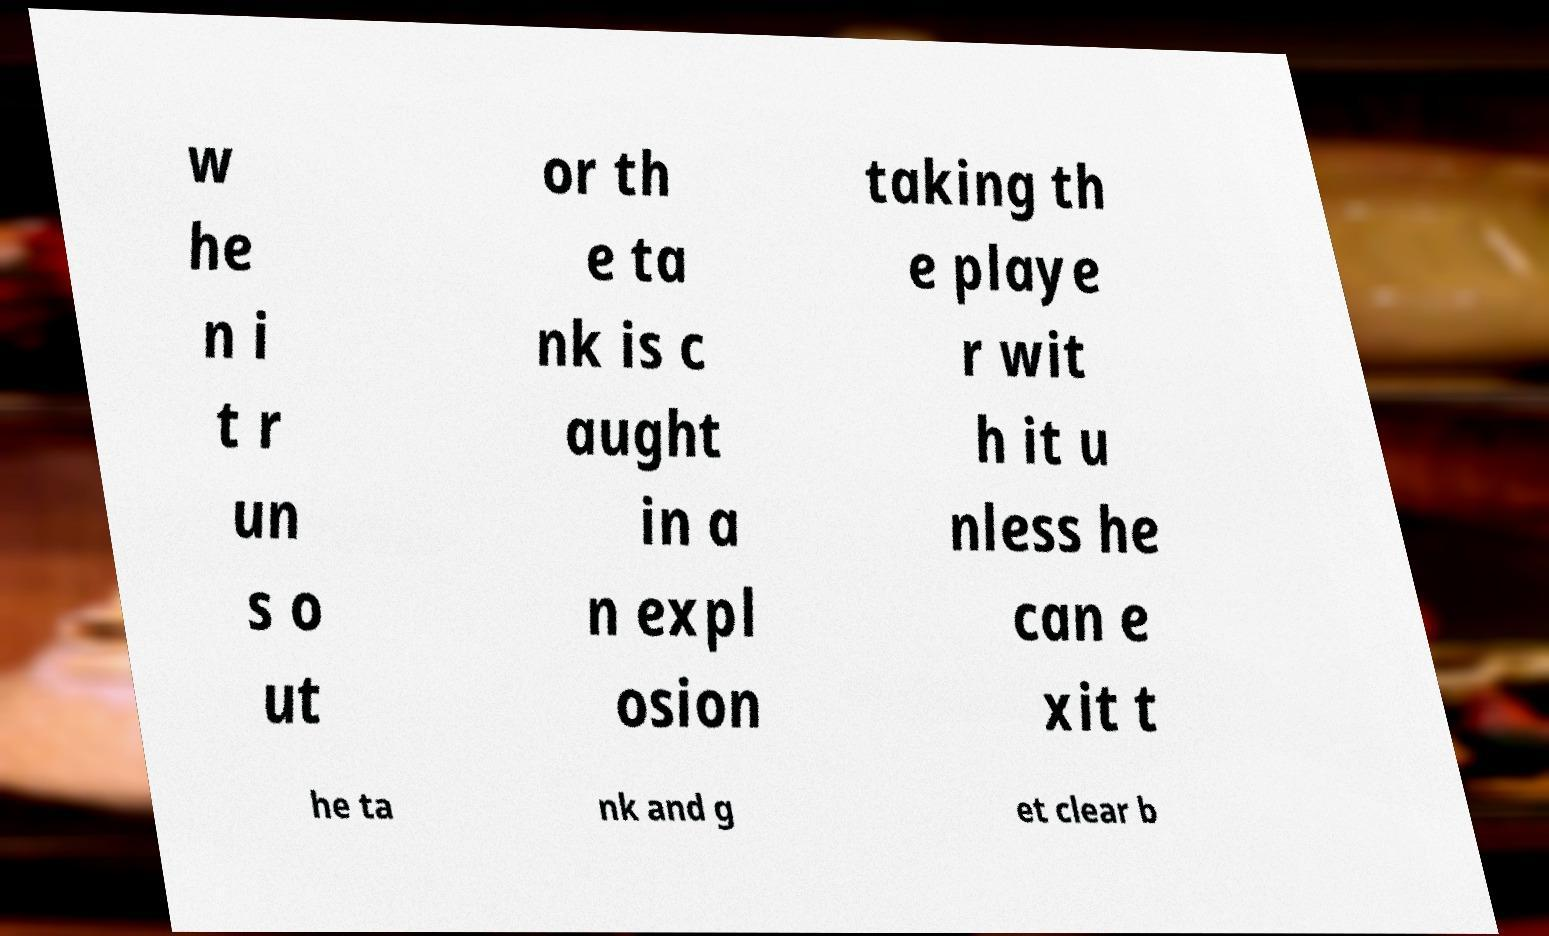Please read and relay the text visible in this image. What does it say? w he n i t r un s o ut or th e ta nk is c aught in a n expl osion taking th e playe r wit h it u nless he can e xit t he ta nk and g et clear b 